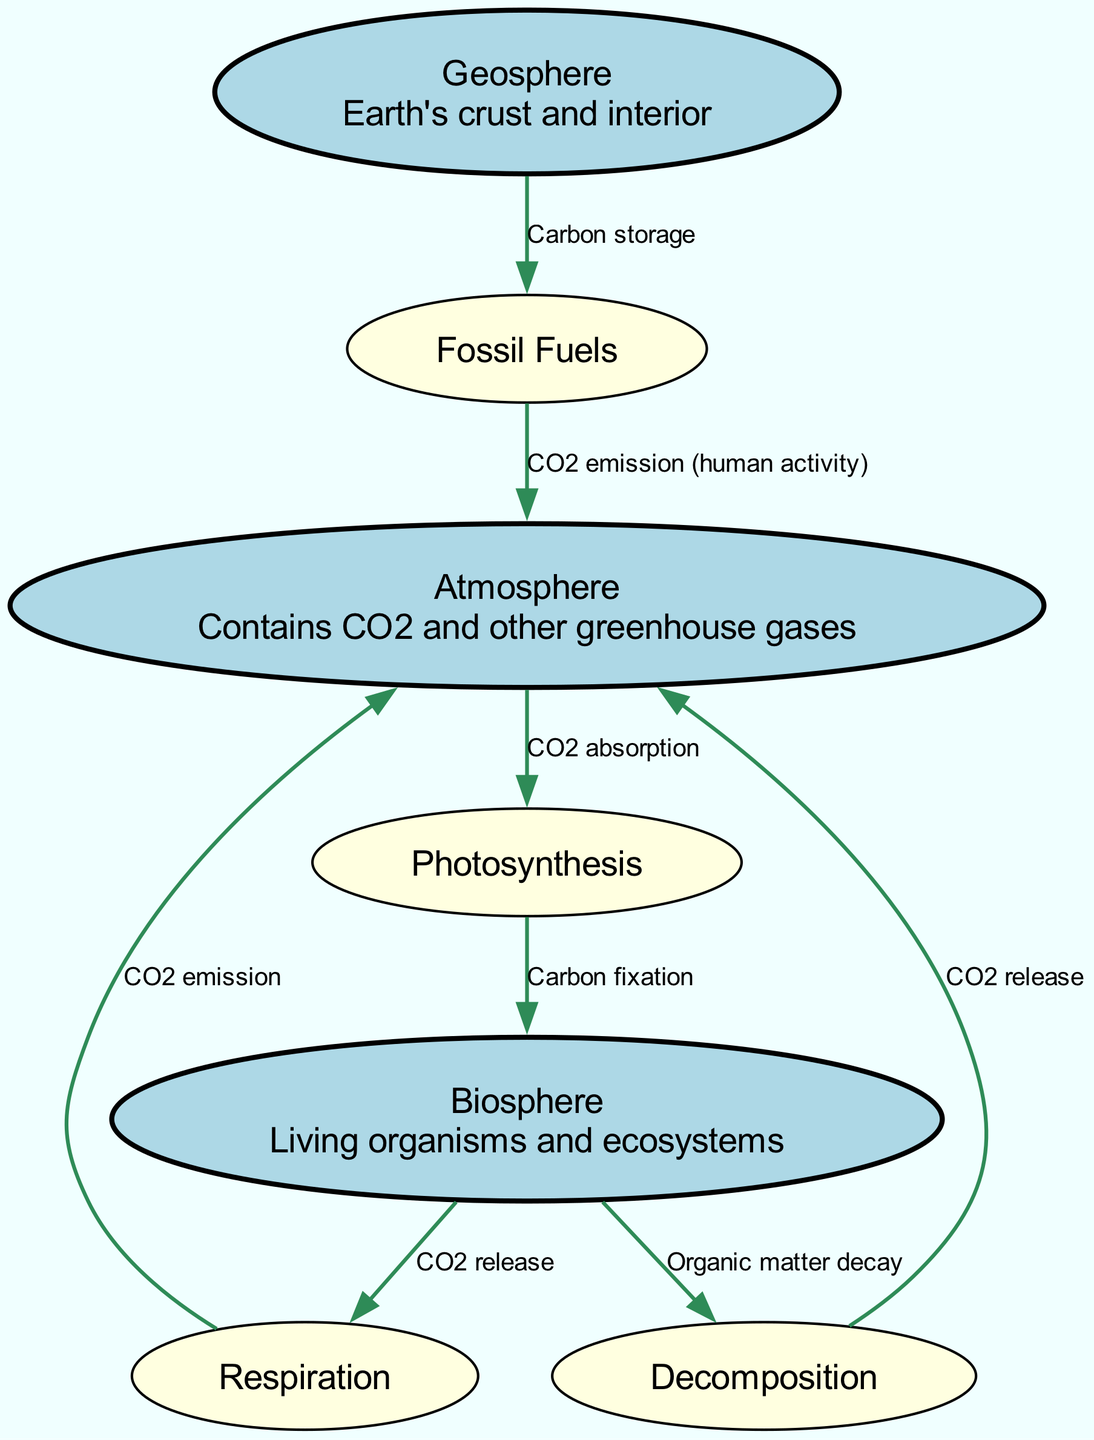What are the three main components of the carbon cycle? The diagram clearly presents three main components identified as "Atmosphere," "Biosphere," and "Geosphere." These represent the different spheres in which carbon interacts.
Answer: Atmosphere, Biosphere, Geosphere How many nodes are present in the diagram? Counting all the unique nodes listed in the data, we find there are seven nodes: Atmosphere, Biosphere, Geosphere, Photosynthesis, Respiration, Decomposition, and Fossil Fuels.
Answer: 7 What process allows plants to absorb CO2? The diagram indicates "Photosynthesis" as the process where plants absorb carbon dioxide (CO2) from the atmosphere. This is illustrated with an arrow from "Atmosphere" to "Photosynthesis."
Answer: Photosynthesis What releases CO2 back into the atmosphere from living organisms? The diagram demonstrates that "Respiration" is the process by which organisms release carbon dioxide back into the atmosphere. This is shown through an edge from "Biosphere" to "Respiration," and then another from "Respiration" to "Atmosphere."
Answer: Respiration What is carbon storage in the Earth's crust referred to as? The term used in the diagram to refer to carbon storage in the Earth's crust is "Fossil Fuels," which is represented as a node linked from "Geosphere."
Answer: Fossil Fuels Explain the flow of carbon from fossil fuels to the atmosphere. The flow starts at the "Fossil Fuels" node, which is connected to the "Atmosphere" node via CO2 emissions related to human activity. The edge indicates this movement of carbon back into the atmosphere. Therefore, the process is human activity causing CO2 emissions from fossil fuels to return to the atmosphere.
Answer: Human activity Which decomposition process is shown to contribute to atmospheric CO2? The diagram shows "Decomposition" as the process that breaks down organic matter and releases CO2 into the atmosphere. This is indicated by an edge leading from "Decomposition" to "Atmosphere," highlighting its direct contribution.
Answer: Decomposition What arrows indicate carbon cycling between living organisms and the environment? There are two arrows indicating this: one from "Photosynthesis" to "Biosphere" illustrating carbon fixation (absorption by plants) and another from "Biosphere" to "Respiration" indicating the release of CO2 when organisms respire, thereby cycling carbon between living organisms and the environment.
Answer: Photosynthesis and Respiration 